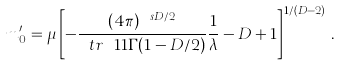Convert formula to latex. <formula><loc_0><loc_0><loc_500><loc_500>m ^ { \prime } _ { 0 } = \mu \left [ - \frac { ( 4 \pi ) ^ { \ s D / 2 } } { \ t r \ 1 1 \Gamma ( 1 - D / 2 ) } \frac { 1 } { \lambda } - D + 1 \right ] ^ { 1 / ( D - 2 ) } \, .</formula> 